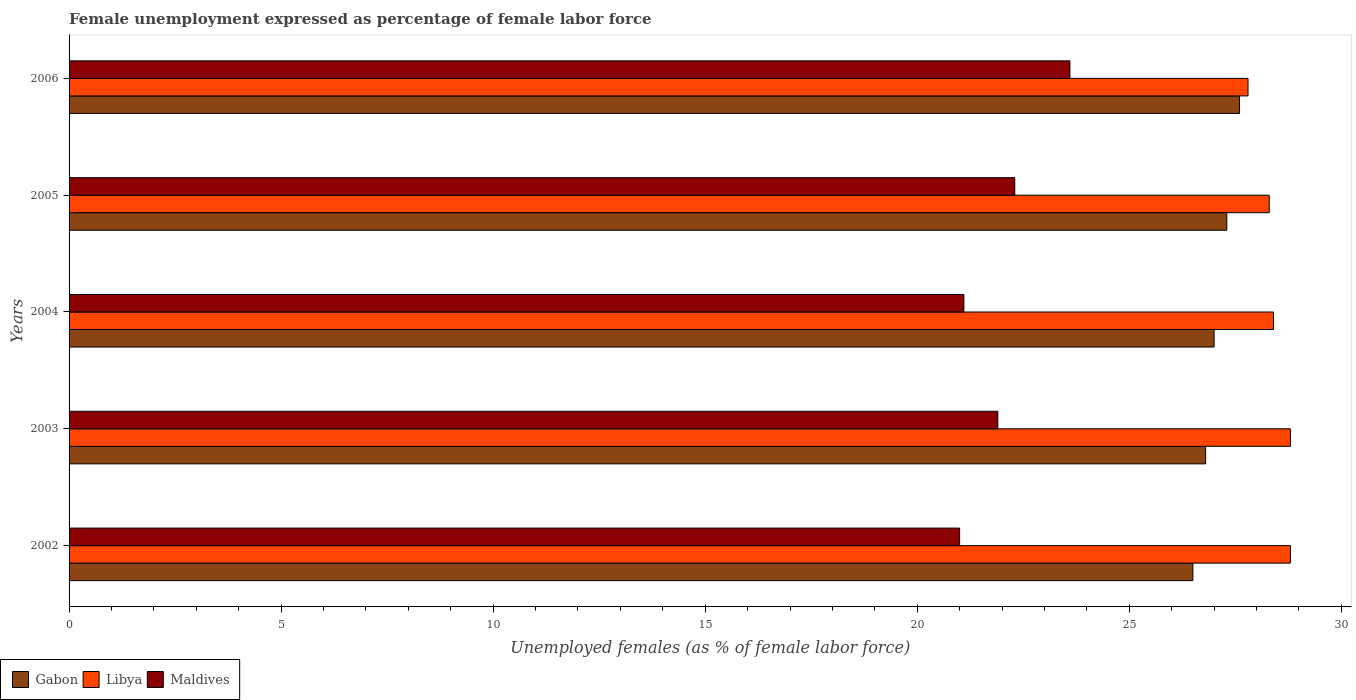How many different coloured bars are there?
Your answer should be compact. 3. How many bars are there on the 3rd tick from the bottom?
Your response must be concise. 3. What is the label of the 5th group of bars from the top?
Provide a short and direct response. 2002. In how many cases, is the number of bars for a given year not equal to the number of legend labels?
Offer a very short reply. 0. What is the unemployment in females in in Libya in 2002?
Your answer should be very brief. 28.8. Across all years, what is the maximum unemployment in females in in Libya?
Ensure brevity in your answer.  28.8. In which year was the unemployment in females in in Libya minimum?
Provide a succinct answer. 2006. What is the total unemployment in females in in Libya in the graph?
Make the answer very short. 142.1. What is the difference between the unemployment in females in in Gabon in 2002 and that in 2005?
Ensure brevity in your answer.  -0.8. What is the difference between the unemployment in females in in Libya in 2004 and the unemployment in females in in Gabon in 2006?
Your answer should be very brief. 0.8. What is the average unemployment in females in in Gabon per year?
Provide a succinct answer. 27.04. In the year 2006, what is the difference between the unemployment in females in in Libya and unemployment in females in in Gabon?
Offer a terse response. 0.2. What is the ratio of the unemployment in females in in Gabon in 2003 to that in 2005?
Ensure brevity in your answer.  0.98. Is the difference between the unemployment in females in in Libya in 2002 and 2003 greater than the difference between the unemployment in females in in Gabon in 2002 and 2003?
Offer a very short reply. Yes. What is the difference between the highest and the lowest unemployment in females in in Gabon?
Your response must be concise. 1.1. In how many years, is the unemployment in females in in Libya greater than the average unemployment in females in in Libya taken over all years?
Give a very brief answer. 2. What does the 1st bar from the top in 2003 represents?
Offer a terse response. Maldives. What does the 3rd bar from the bottom in 2005 represents?
Ensure brevity in your answer.  Maldives. Is it the case that in every year, the sum of the unemployment in females in in Maldives and unemployment in females in in Libya is greater than the unemployment in females in in Gabon?
Provide a short and direct response. Yes. Are all the bars in the graph horizontal?
Ensure brevity in your answer.  Yes. How many legend labels are there?
Make the answer very short. 3. What is the title of the graph?
Your answer should be compact. Female unemployment expressed as percentage of female labor force. Does "Aruba" appear as one of the legend labels in the graph?
Your answer should be very brief. No. What is the label or title of the X-axis?
Your answer should be very brief. Unemployed females (as % of female labor force). What is the Unemployed females (as % of female labor force) of Libya in 2002?
Your answer should be very brief. 28.8. What is the Unemployed females (as % of female labor force) of Maldives in 2002?
Your answer should be compact. 21. What is the Unemployed females (as % of female labor force) in Gabon in 2003?
Keep it short and to the point. 26.8. What is the Unemployed females (as % of female labor force) of Libya in 2003?
Offer a terse response. 28.8. What is the Unemployed females (as % of female labor force) in Maldives in 2003?
Make the answer very short. 21.9. What is the Unemployed females (as % of female labor force) of Libya in 2004?
Your answer should be very brief. 28.4. What is the Unemployed females (as % of female labor force) in Maldives in 2004?
Your response must be concise. 21.1. What is the Unemployed females (as % of female labor force) of Gabon in 2005?
Give a very brief answer. 27.3. What is the Unemployed females (as % of female labor force) of Libya in 2005?
Provide a succinct answer. 28.3. What is the Unemployed females (as % of female labor force) of Maldives in 2005?
Ensure brevity in your answer.  22.3. What is the Unemployed females (as % of female labor force) of Gabon in 2006?
Your answer should be very brief. 27.6. What is the Unemployed females (as % of female labor force) of Libya in 2006?
Offer a terse response. 27.8. What is the Unemployed females (as % of female labor force) in Maldives in 2006?
Offer a very short reply. 23.6. Across all years, what is the maximum Unemployed females (as % of female labor force) in Gabon?
Your response must be concise. 27.6. Across all years, what is the maximum Unemployed females (as % of female labor force) in Libya?
Make the answer very short. 28.8. Across all years, what is the maximum Unemployed females (as % of female labor force) in Maldives?
Ensure brevity in your answer.  23.6. Across all years, what is the minimum Unemployed females (as % of female labor force) of Libya?
Make the answer very short. 27.8. Across all years, what is the minimum Unemployed females (as % of female labor force) in Maldives?
Your response must be concise. 21. What is the total Unemployed females (as % of female labor force) in Gabon in the graph?
Give a very brief answer. 135.2. What is the total Unemployed females (as % of female labor force) of Libya in the graph?
Your response must be concise. 142.1. What is the total Unemployed females (as % of female labor force) of Maldives in the graph?
Give a very brief answer. 109.9. What is the difference between the Unemployed females (as % of female labor force) in Libya in 2002 and that in 2003?
Your answer should be very brief. 0. What is the difference between the Unemployed females (as % of female labor force) in Gabon in 2002 and that in 2004?
Offer a very short reply. -0.5. What is the difference between the Unemployed females (as % of female labor force) in Libya in 2002 and that in 2005?
Provide a succinct answer. 0.5. What is the difference between the Unemployed females (as % of female labor force) in Maldives in 2002 and that in 2005?
Make the answer very short. -1.3. What is the difference between the Unemployed females (as % of female labor force) of Maldives in 2002 and that in 2006?
Give a very brief answer. -2.6. What is the difference between the Unemployed females (as % of female labor force) of Gabon in 2003 and that in 2004?
Ensure brevity in your answer.  -0.2. What is the difference between the Unemployed females (as % of female labor force) of Libya in 2003 and that in 2005?
Offer a terse response. 0.5. What is the difference between the Unemployed females (as % of female labor force) in Maldives in 2003 and that in 2005?
Offer a very short reply. -0.4. What is the difference between the Unemployed females (as % of female labor force) in Libya in 2003 and that in 2006?
Provide a short and direct response. 1. What is the difference between the Unemployed females (as % of female labor force) in Maldives in 2003 and that in 2006?
Your answer should be compact. -1.7. What is the difference between the Unemployed females (as % of female labor force) of Libya in 2004 and that in 2005?
Offer a very short reply. 0.1. What is the difference between the Unemployed females (as % of female labor force) of Maldives in 2004 and that in 2005?
Give a very brief answer. -1.2. What is the difference between the Unemployed females (as % of female labor force) of Libya in 2004 and that in 2006?
Your answer should be compact. 0.6. What is the difference between the Unemployed females (as % of female labor force) of Maldives in 2004 and that in 2006?
Your response must be concise. -2.5. What is the difference between the Unemployed females (as % of female labor force) in Gabon in 2005 and that in 2006?
Offer a terse response. -0.3. What is the difference between the Unemployed females (as % of female labor force) of Maldives in 2005 and that in 2006?
Offer a terse response. -1.3. What is the difference between the Unemployed females (as % of female labor force) of Gabon in 2002 and the Unemployed females (as % of female labor force) of Libya in 2003?
Your answer should be very brief. -2.3. What is the difference between the Unemployed females (as % of female labor force) of Gabon in 2002 and the Unemployed females (as % of female labor force) of Maldives in 2003?
Ensure brevity in your answer.  4.6. What is the difference between the Unemployed females (as % of female labor force) of Libya in 2002 and the Unemployed females (as % of female labor force) of Maldives in 2003?
Your answer should be compact. 6.9. What is the difference between the Unemployed females (as % of female labor force) of Gabon in 2002 and the Unemployed females (as % of female labor force) of Libya in 2004?
Provide a short and direct response. -1.9. What is the difference between the Unemployed females (as % of female labor force) of Gabon in 2002 and the Unemployed females (as % of female labor force) of Maldives in 2004?
Your answer should be compact. 5.4. What is the difference between the Unemployed females (as % of female labor force) in Gabon in 2002 and the Unemployed females (as % of female labor force) in Maldives in 2005?
Your answer should be very brief. 4.2. What is the difference between the Unemployed females (as % of female labor force) in Libya in 2002 and the Unemployed females (as % of female labor force) in Maldives in 2005?
Your response must be concise. 6.5. What is the difference between the Unemployed females (as % of female labor force) in Gabon in 2002 and the Unemployed females (as % of female labor force) in Libya in 2006?
Provide a succinct answer. -1.3. What is the difference between the Unemployed females (as % of female labor force) in Gabon in 2002 and the Unemployed females (as % of female labor force) in Maldives in 2006?
Provide a short and direct response. 2.9. What is the difference between the Unemployed females (as % of female labor force) of Libya in 2002 and the Unemployed females (as % of female labor force) of Maldives in 2006?
Offer a very short reply. 5.2. What is the difference between the Unemployed females (as % of female labor force) in Gabon in 2003 and the Unemployed females (as % of female labor force) in Libya in 2005?
Ensure brevity in your answer.  -1.5. What is the difference between the Unemployed females (as % of female labor force) in Gabon in 2003 and the Unemployed females (as % of female labor force) in Libya in 2006?
Offer a terse response. -1. What is the difference between the Unemployed females (as % of female labor force) in Gabon in 2003 and the Unemployed females (as % of female labor force) in Maldives in 2006?
Give a very brief answer. 3.2. What is the difference between the Unemployed females (as % of female labor force) in Libya in 2003 and the Unemployed females (as % of female labor force) in Maldives in 2006?
Offer a very short reply. 5.2. What is the difference between the Unemployed females (as % of female labor force) of Gabon in 2004 and the Unemployed females (as % of female labor force) of Maldives in 2005?
Keep it short and to the point. 4.7. What is the difference between the Unemployed females (as % of female labor force) of Libya in 2004 and the Unemployed females (as % of female labor force) of Maldives in 2005?
Your response must be concise. 6.1. What is the difference between the Unemployed females (as % of female labor force) in Gabon in 2004 and the Unemployed females (as % of female labor force) in Libya in 2006?
Make the answer very short. -0.8. What is the difference between the Unemployed females (as % of female labor force) in Gabon in 2004 and the Unemployed females (as % of female labor force) in Maldives in 2006?
Your response must be concise. 3.4. What is the difference between the Unemployed females (as % of female labor force) in Libya in 2004 and the Unemployed females (as % of female labor force) in Maldives in 2006?
Your response must be concise. 4.8. What is the difference between the Unemployed females (as % of female labor force) of Gabon in 2005 and the Unemployed females (as % of female labor force) of Libya in 2006?
Ensure brevity in your answer.  -0.5. What is the difference between the Unemployed females (as % of female labor force) in Libya in 2005 and the Unemployed females (as % of female labor force) in Maldives in 2006?
Provide a short and direct response. 4.7. What is the average Unemployed females (as % of female labor force) of Gabon per year?
Give a very brief answer. 27.04. What is the average Unemployed females (as % of female labor force) in Libya per year?
Offer a very short reply. 28.42. What is the average Unemployed females (as % of female labor force) of Maldives per year?
Ensure brevity in your answer.  21.98. In the year 2002, what is the difference between the Unemployed females (as % of female labor force) of Gabon and Unemployed females (as % of female labor force) of Libya?
Offer a terse response. -2.3. In the year 2002, what is the difference between the Unemployed females (as % of female labor force) of Gabon and Unemployed females (as % of female labor force) of Maldives?
Keep it short and to the point. 5.5. In the year 2003, what is the difference between the Unemployed females (as % of female labor force) in Gabon and Unemployed females (as % of female labor force) in Libya?
Offer a very short reply. -2. In the year 2003, what is the difference between the Unemployed females (as % of female labor force) of Gabon and Unemployed females (as % of female labor force) of Maldives?
Provide a succinct answer. 4.9. In the year 2004, what is the difference between the Unemployed females (as % of female labor force) in Gabon and Unemployed females (as % of female labor force) in Maldives?
Your answer should be very brief. 5.9. In the year 2005, what is the difference between the Unemployed females (as % of female labor force) in Gabon and Unemployed females (as % of female labor force) in Libya?
Your response must be concise. -1. In the year 2005, what is the difference between the Unemployed females (as % of female labor force) of Libya and Unemployed females (as % of female labor force) of Maldives?
Your response must be concise. 6. What is the ratio of the Unemployed females (as % of female labor force) in Gabon in 2002 to that in 2003?
Your answer should be very brief. 0.99. What is the ratio of the Unemployed females (as % of female labor force) in Maldives in 2002 to that in 2003?
Keep it short and to the point. 0.96. What is the ratio of the Unemployed females (as % of female labor force) of Gabon in 2002 to that in 2004?
Your response must be concise. 0.98. What is the ratio of the Unemployed females (as % of female labor force) in Libya in 2002 to that in 2004?
Give a very brief answer. 1.01. What is the ratio of the Unemployed females (as % of female labor force) in Gabon in 2002 to that in 2005?
Make the answer very short. 0.97. What is the ratio of the Unemployed females (as % of female labor force) of Libya in 2002 to that in 2005?
Give a very brief answer. 1.02. What is the ratio of the Unemployed females (as % of female labor force) of Maldives in 2002 to that in 2005?
Give a very brief answer. 0.94. What is the ratio of the Unemployed females (as % of female labor force) of Gabon in 2002 to that in 2006?
Your answer should be compact. 0.96. What is the ratio of the Unemployed females (as % of female labor force) in Libya in 2002 to that in 2006?
Provide a succinct answer. 1.04. What is the ratio of the Unemployed females (as % of female labor force) in Maldives in 2002 to that in 2006?
Give a very brief answer. 0.89. What is the ratio of the Unemployed females (as % of female labor force) in Gabon in 2003 to that in 2004?
Your response must be concise. 0.99. What is the ratio of the Unemployed females (as % of female labor force) in Libya in 2003 to that in 2004?
Make the answer very short. 1.01. What is the ratio of the Unemployed females (as % of female labor force) in Maldives in 2003 to that in 2004?
Keep it short and to the point. 1.04. What is the ratio of the Unemployed females (as % of female labor force) of Gabon in 2003 to that in 2005?
Give a very brief answer. 0.98. What is the ratio of the Unemployed females (as % of female labor force) in Libya in 2003 to that in 2005?
Offer a very short reply. 1.02. What is the ratio of the Unemployed females (as % of female labor force) of Maldives in 2003 to that in 2005?
Offer a very short reply. 0.98. What is the ratio of the Unemployed females (as % of female labor force) in Libya in 2003 to that in 2006?
Ensure brevity in your answer.  1.04. What is the ratio of the Unemployed females (as % of female labor force) of Maldives in 2003 to that in 2006?
Your answer should be compact. 0.93. What is the ratio of the Unemployed females (as % of female labor force) of Gabon in 2004 to that in 2005?
Offer a very short reply. 0.99. What is the ratio of the Unemployed females (as % of female labor force) in Maldives in 2004 to that in 2005?
Provide a short and direct response. 0.95. What is the ratio of the Unemployed females (as % of female labor force) in Gabon in 2004 to that in 2006?
Make the answer very short. 0.98. What is the ratio of the Unemployed females (as % of female labor force) of Libya in 2004 to that in 2006?
Your answer should be very brief. 1.02. What is the ratio of the Unemployed females (as % of female labor force) of Maldives in 2004 to that in 2006?
Your answer should be compact. 0.89. What is the ratio of the Unemployed females (as % of female labor force) in Maldives in 2005 to that in 2006?
Make the answer very short. 0.94. What is the difference between the highest and the second highest Unemployed females (as % of female labor force) of Libya?
Your answer should be very brief. 0. What is the difference between the highest and the second highest Unemployed females (as % of female labor force) of Maldives?
Provide a succinct answer. 1.3. What is the difference between the highest and the lowest Unemployed females (as % of female labor force) of Gabon?
Keep it short and to the point. 1.1. 